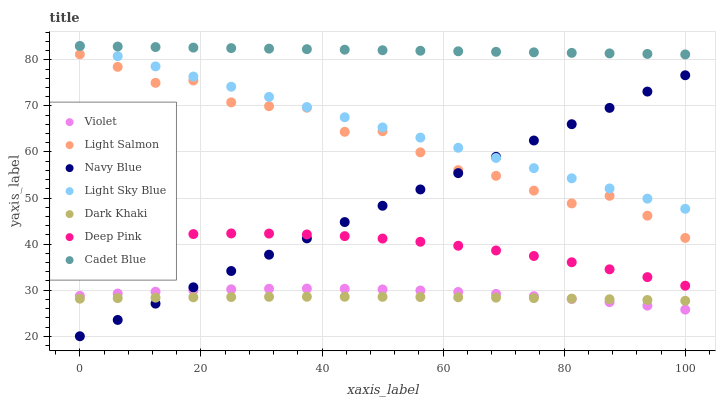Does Dark Khaki have the minimum area under the curve?
Answer yes or no. Yes. Does Cadet Blue have the maximum area under the curve?
Answer yes or no. Yes. Does Deep Pink have the minimum area under the curve?
Answer yes or no. No. Does Deep Pink have the maximum area under the curve?
Answer yes or no. No. Is Cadet Blue the smoothest?
Answer yes or no. Yes. Is Light Salmon the roughest?
Answer yes or no. Yes. Is Deep Pink the smoothest?
Answer yes or no. No. Is Deep Pink the roughest?
Answer yes or no. No. Does Navy Blue have the lowest value?
Answer yes or no. Yes. Does Deep Pink have the lowest value?
Answer yes or no. No. Does Light Sky Blue have the highest value?
Answer yes or no. Yes. Does Deep Pink have the highest value?
Answer yes or no. No. Is Violet less than Cadet Blue?
Answer yes or no. Yes. Is Light Sky Blue greater than Light Salmon?
Answer yes or no. Yes. Does Violet intersect Dark Khaki?
Answer yes or no. Yes. Is Violet less than Dark Khaki?
Answer yes or no. No. Is Violet greater than Dark Khaki?
Answer yes or no. No. Does Violet intersect Cadet Blue?
Answer yes or no. No. 